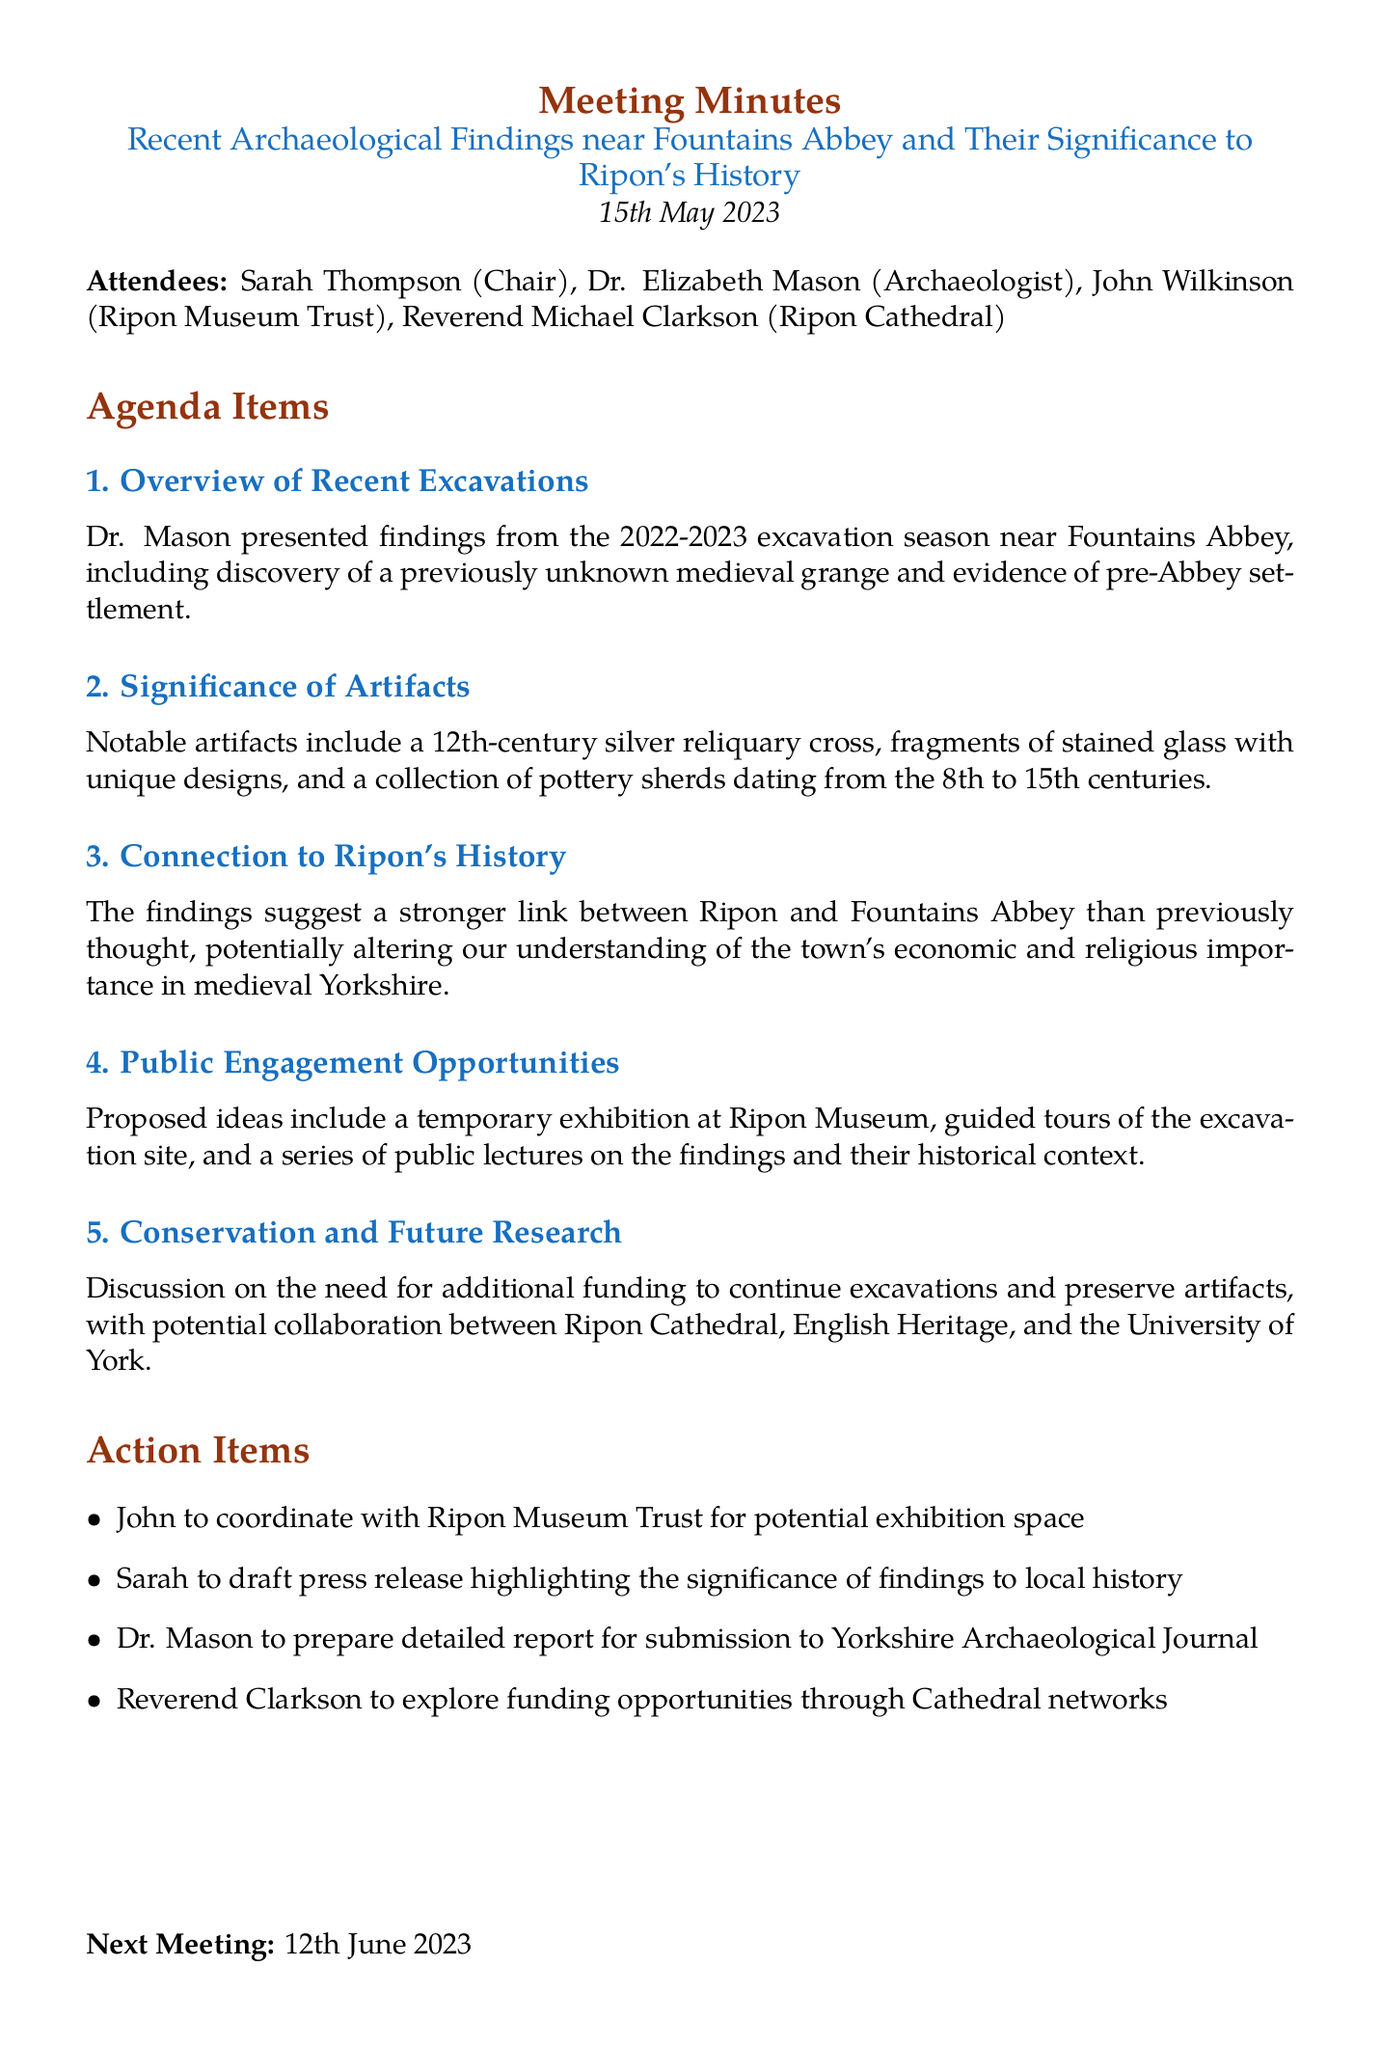What is the date of the meeting? The date of the meeting is mentioned at the beginning of the document.
Answer: 15th May 2023 Who chaired the meeting? The chairperson of the meeting is listed in the attendee section of the document.
Answer: Sarah Thompson What notable artifact was highlighted during the meeting? The document mentions notable artifacts discussed in the agenda item about their significance.
Answer: 12th-century silver reliquary cross What is the next meeting date? The next meeting date is specified at the end of the document.
Answer: 12th June 2023 What was discovered during the excavations? The overview of recent excavations provides details on what was discovered.
Answer: Previously unknown medieval grange How does the new finding alter our understanding of Ripon's history? The connection to Ripon's history section describes how the findings impact historical understanding.
Answer: Suggest a stronger link between Ripon and Fountains Abbey What type of public engagement opportunities were proposed? The public engagement opportunities section outlines ideas for community involvement with the findings.
Answer: Temporary exhibition at Ripon Museum What action item involves the Ripon Museum Trust? The action items list specifies tasks assigned to attendees after the meeting.
Answer: John to coordinate with Ripon Museum Trust for potential exhibition space 